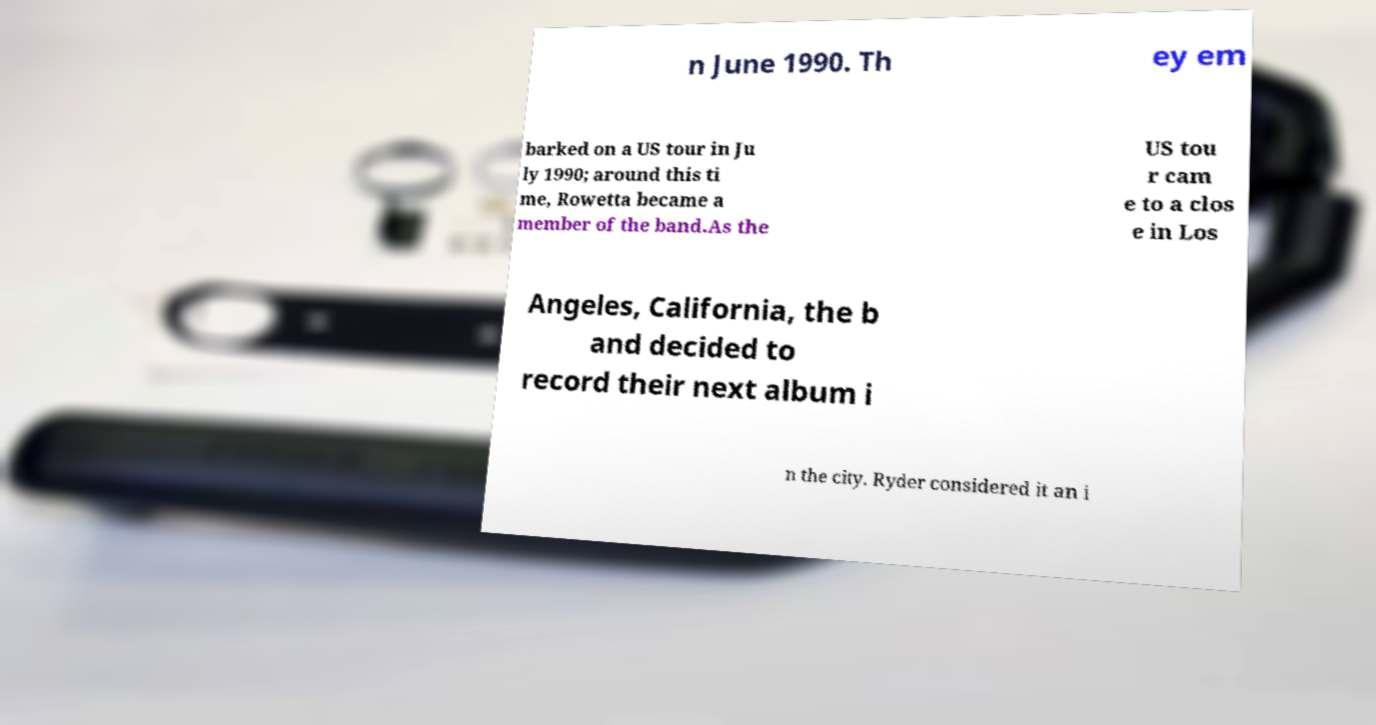What messages or text are displayed in this image? I need them in a readable, typed format. n June 1990. Th ey em barked on a US tour in Ju ly 1990; around this ti me, Rowetta became a member of the band.As the US tou r cam e to a clos e in Los Angeles, California, the b and decided to record their next album i n the city. Ryder considered it an i 